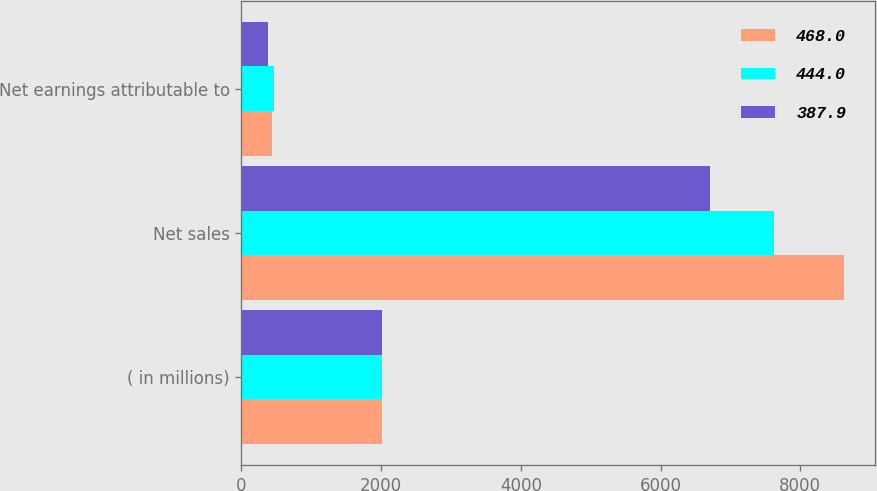<chart> <loc_0><loc_0><loc_500><loc_500><stacked_bar_chart><ecel><fcel>( in millions)<fcel>Net sales<fcel>Net earnings attributable to<nl><fcel>468<fcel>2011<fcel>8630.9<fcel>444<nl><fcel>444<fcel>2010<fcel>7630<fcel>468<nl><fcel>387.9<fcel>2009<fcel>6710.4<fcel>387.9<nl></chart> 